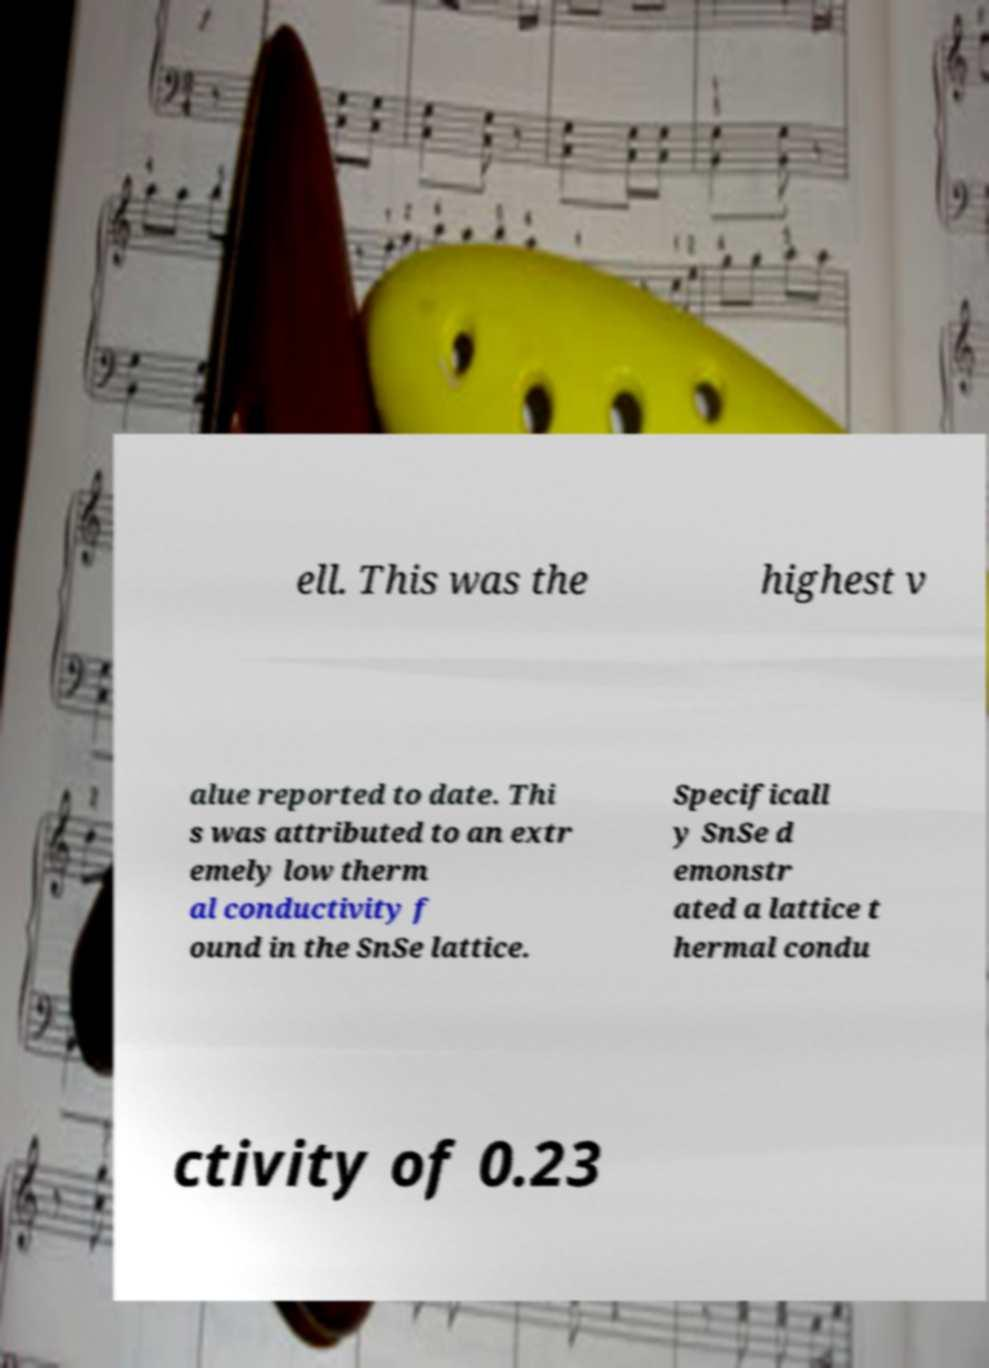What messages or text are displayed in this image? I need them in a readable, typed format. ell. This was the highest v alue reported to date. Thi s was attributed to an extr emely low therm al conductivity f ound in the SnSe lattice. Specificall y SnSe d emonstr ated a lattice t hermal condu ctivity of 0.23 